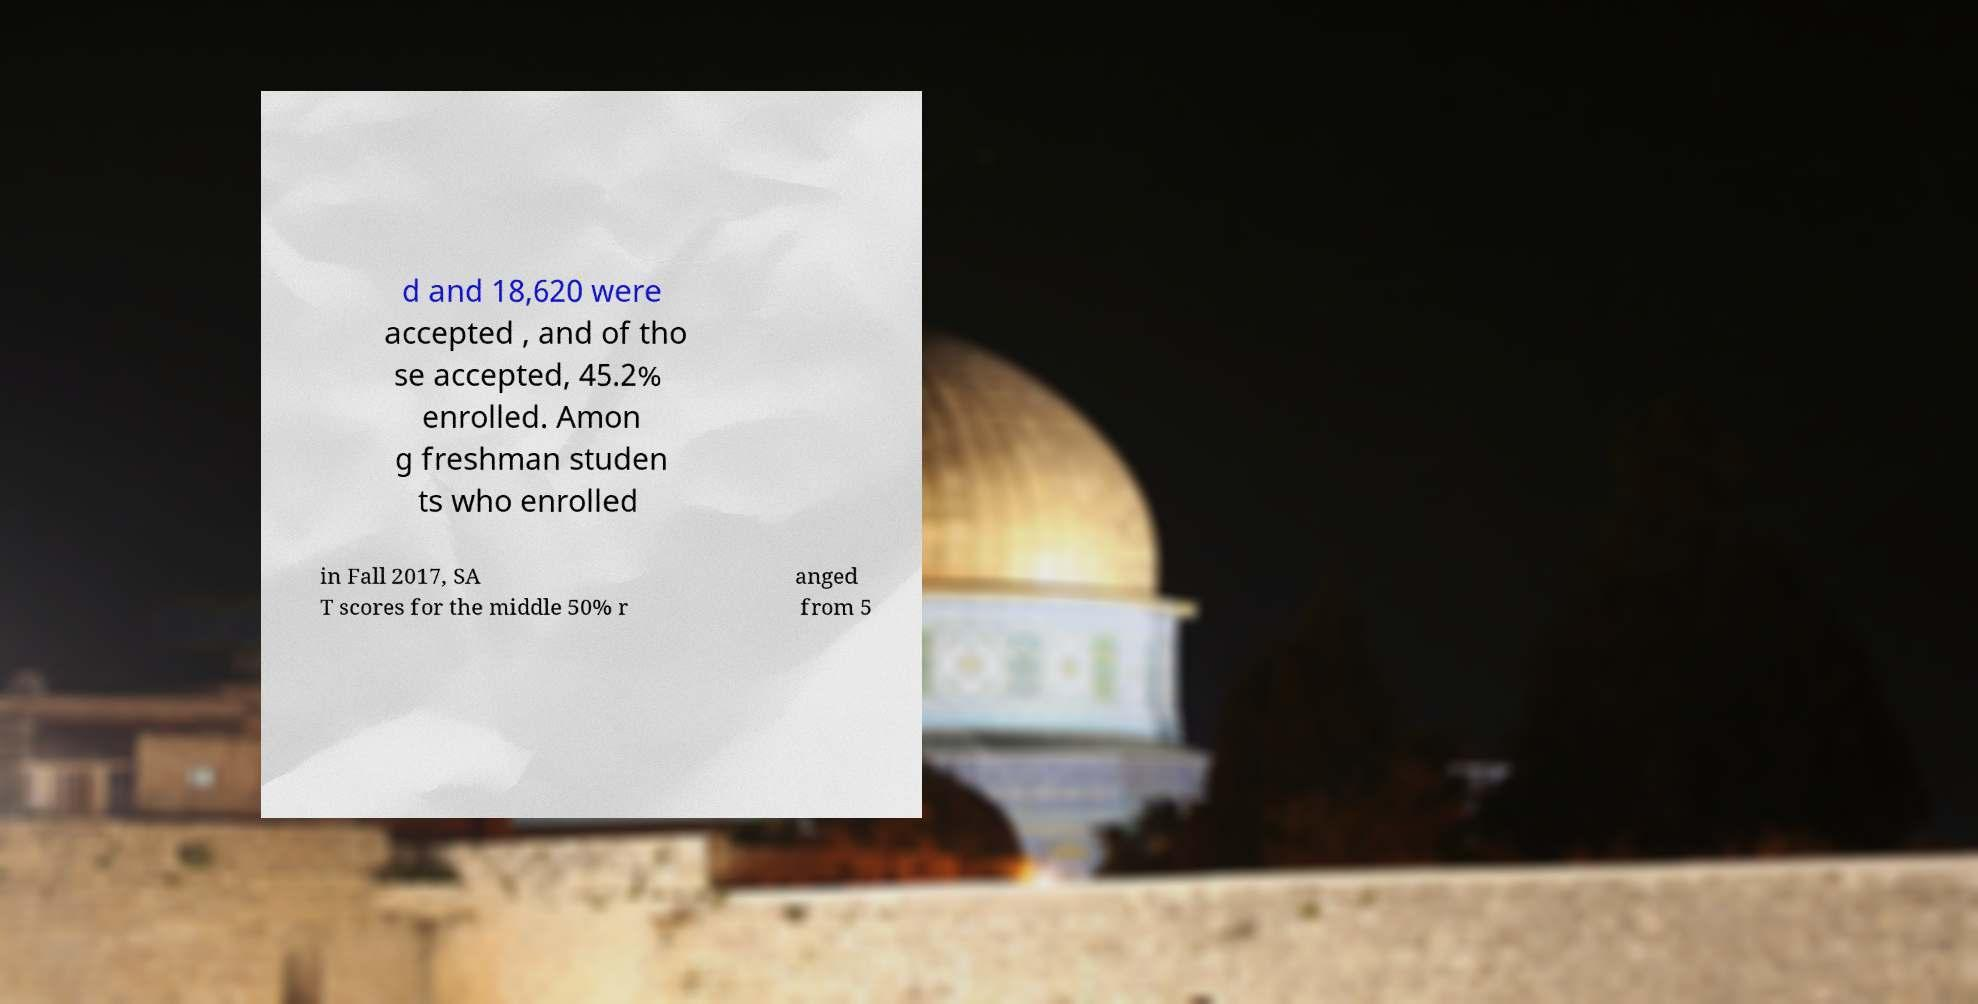I need the written content from this picture converted into text. Can you do that? d and 18,620 were accepted , and of tho se accepted, 45.2% enrolled. Amon g freshman studen ts who enrolled in Fall 2017, SA T scores for the middle 50% r anged from 5 